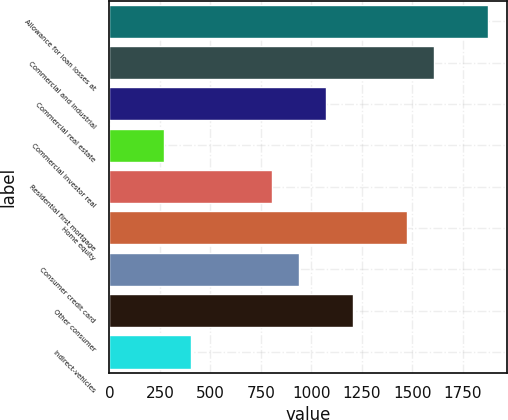Convert chart. <chart><loc_0><loc_0><loc_500><loc_500><bar_chart><fcel>Allowance for loan losses at<fcel>Commercial and industrial<fcel>Commercial real estate<fcel>Commercial investor real<fcel>Residential first mortgage<fcel>Home equity<fcel>Consumer credit card<fcel>Other consumer<fcel>Indirect-vehicles<nl><fcel>1877.24<fcel>1609.12<fcel>1072.88<fcel>268.52<fcel>804.76<fcel>1475.06<fcel>938.82<fcel>1206.94<fcel>402.58<nl></chart> 